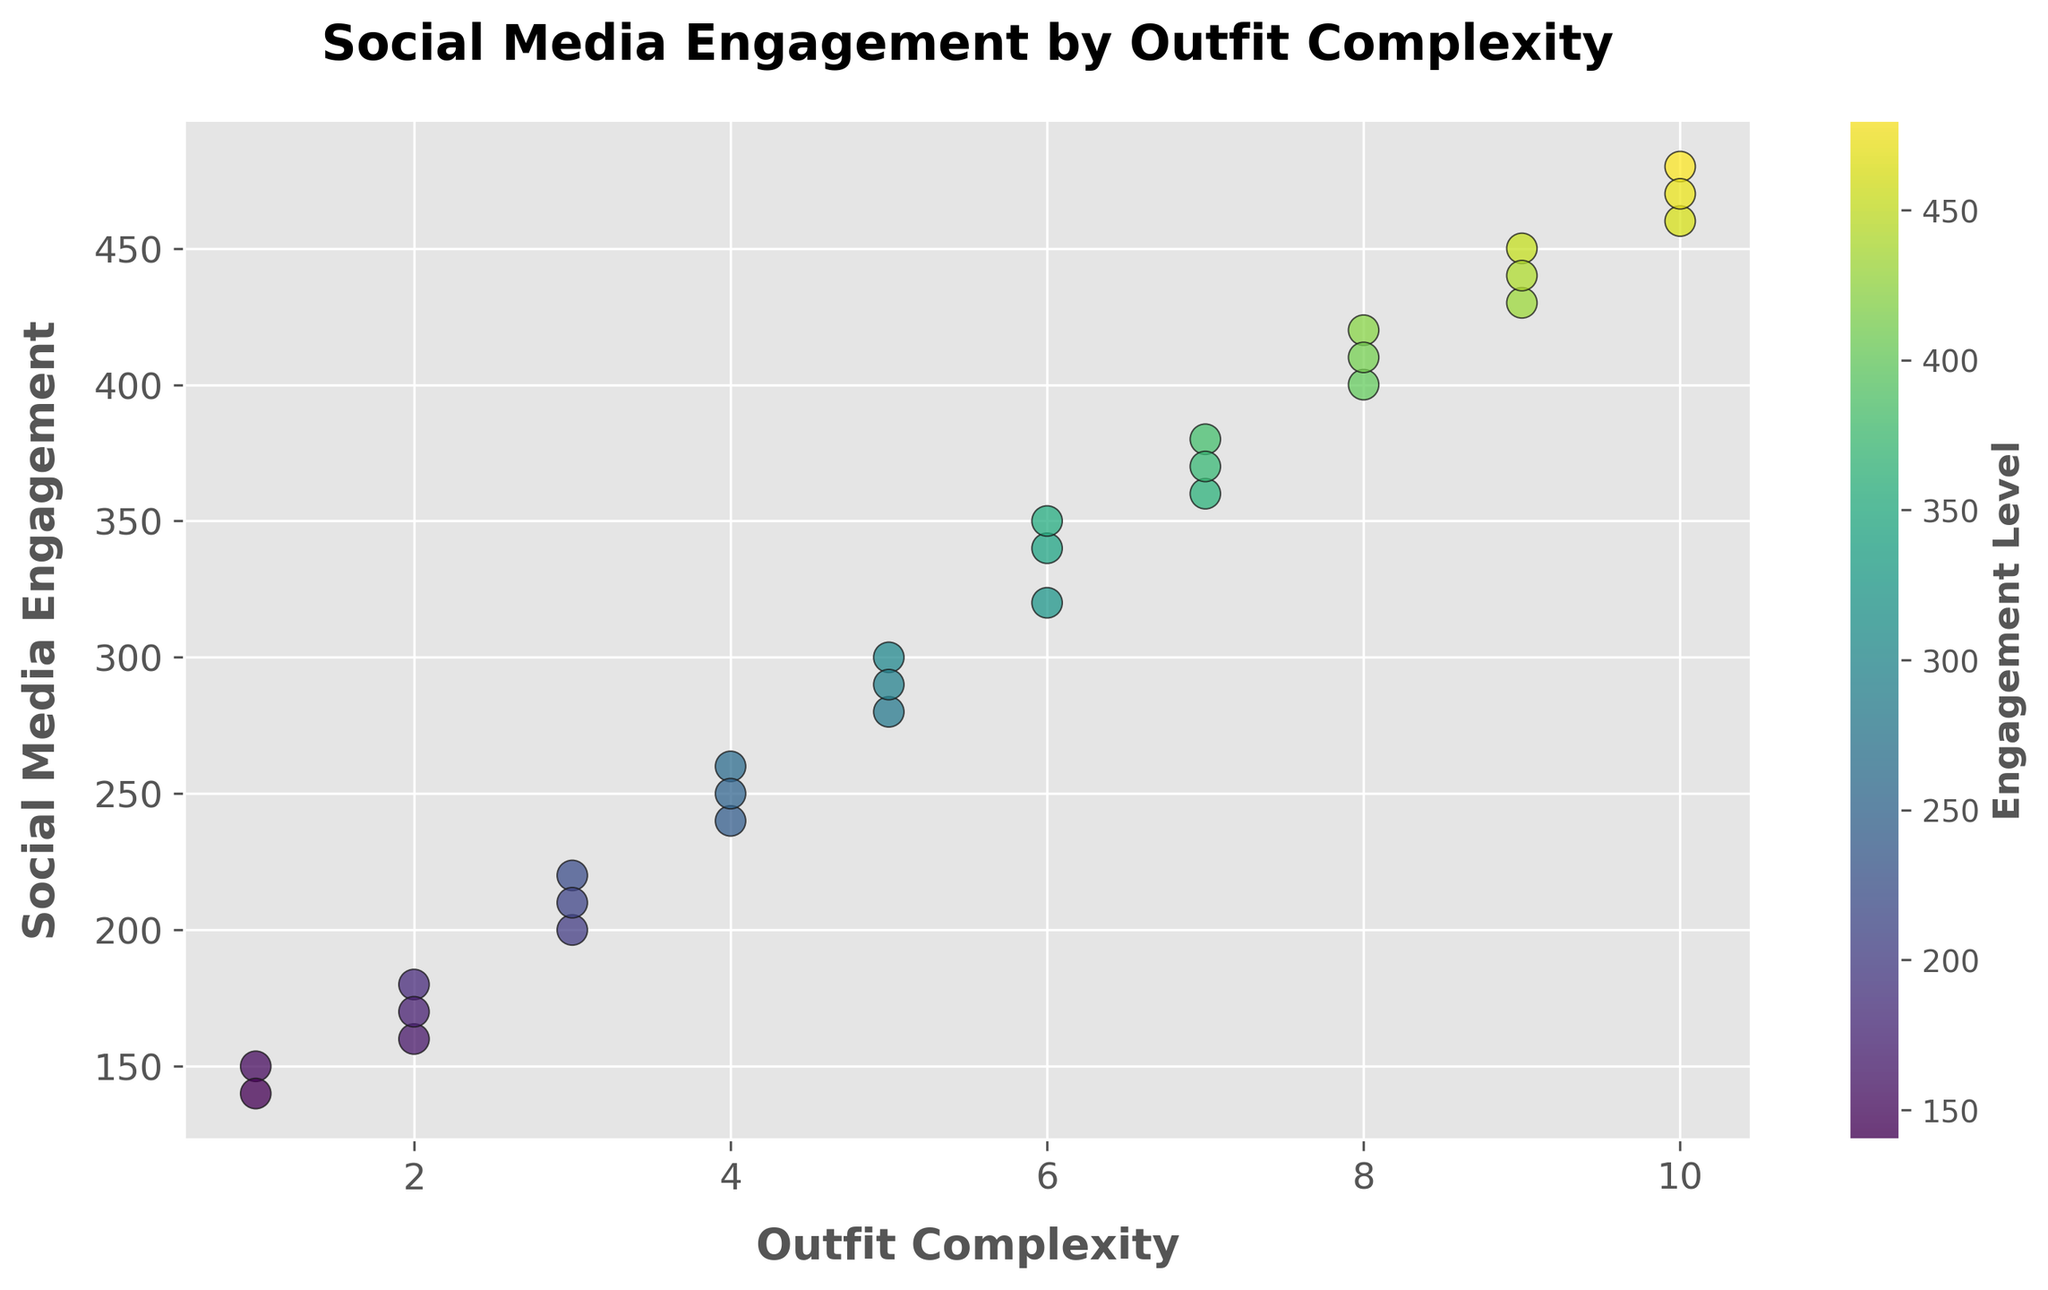What's the highest social media engagement value for outfit complexities ranging from 1 to 5? To find this, identify points where the x-axis values (Outfit Complexity) are in the range 1 to 5 and observe the corresponding y-axis values (Social Media Engagement). The highest value among these is 300 at Outfit Complexity 5.
Answer: 300 Is there a visible trend between outfit complexity and social media engagement? By observing the scatter plot, one can see that as outfit complexity increases, the social media engagement also tends to increase. This indicates a positive correlation between outfit complexity and social media engagement.
Answer: Yes, a positive trend What is the average social media engagement at outfit complexity 8? Locate all the points where outfit complexity is 8 and average their social media engagement. The values are 420 and 400. Hence, the average = (420 + 400) / 2 = 410.
Answer: 410 Comparing outfit complexities 7 and 9, which has a higher median engagement? Identify the points for complexities 7 and 9: For 7, engagement values are 380 and 370 (median is 375). For 9, values are 450 and 430 (median is 440). So, complexity 9 has a higher median engagement.
Answer: Outfit complexity 9 Are there any outliers in the social media engagement for outfit complexity 10? Check the engagement values for complexity 10: they are 480, 470, and 460. The values are close to each other, indicating no outliers in engagement at outfit complexity 10.
Answer: No outliers Which complexity level has the most scattered range of engagement values? Determine the spread of engagement values within each outfit complexity level. Complexity 3, for example, has values ranging from 200 to 220, indicating a narrow range. Complexity 7 has values ranging from 370 to 380, indicating it's more scattered.
Answer: Complexity 7 At what outfit complexity or complexities does social media engagement reach exactly 250? Locate the points on the scatter plot where the y-axis value is 250. This occurs at outfit complexity 4.
Answer: Complexity 4 How does the engagement trend change between outfit complexities 5 and 10? Observe the scatter points from complexity 5 to 10. Engagement values increase steadily from 300 to 480, showing a consistent upward trend.
Answer: Increases steadily 